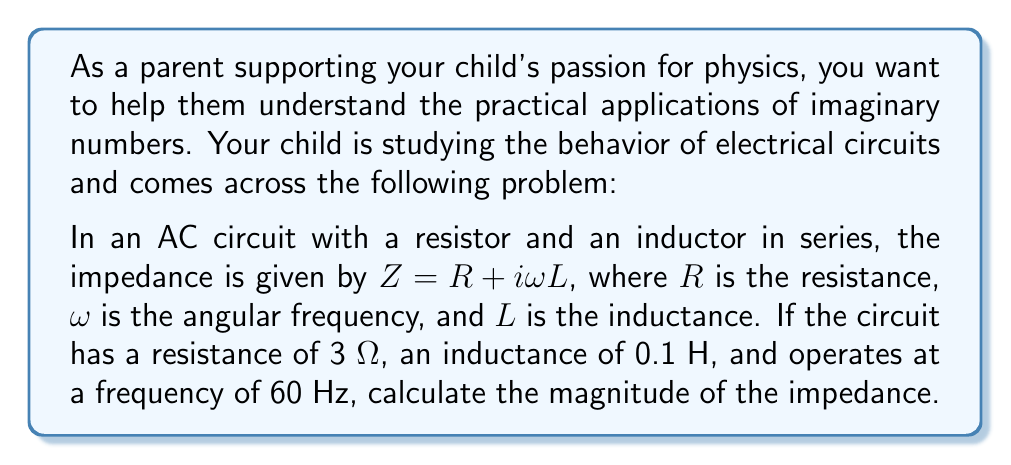Can you solve this math problem? Let's approach this problem step-by-step:

1) First, we need to calculate the angular frequency $\omega$:
   $\omega = 2\pi f$, where $f$ is the frequency in Hz
   $\omega = 2\pi(60) = 120\pi$ rad/s

2) Now we can substitute the values into the impedance equation:
   $Z = R + i\omega L$
   $Z = 3 + i(120\pi)(0.1)$
   $Z = 3 + i(12\pi)$

3) To find the magnitude of the impedance, we use the formula:
   $|Z| = \sqrt{(\text{Real part})^2 + (\text{Imaginary part})^2}$

4) In this case:
   $|Z| = \sqrt{3^2 + (12\pi)^2}$

5) Let's calculate:
   $|Z| = \sqrt{9 + 144\pi^2}$
   $|Z| = \sqrt{9 + 1421.76}$
   $|Z| = \sqrt{1430.76}$
   $|Z| \approx 37.83$ Ω

This demonstrates how imaginary numbers (in this case, the imaginary unit $i$ in the impedance formula) can be used to solve real-world physics problems involving AC circuits.
Answer: The magnitude of the impedance is approximately 37.83 Ω. 